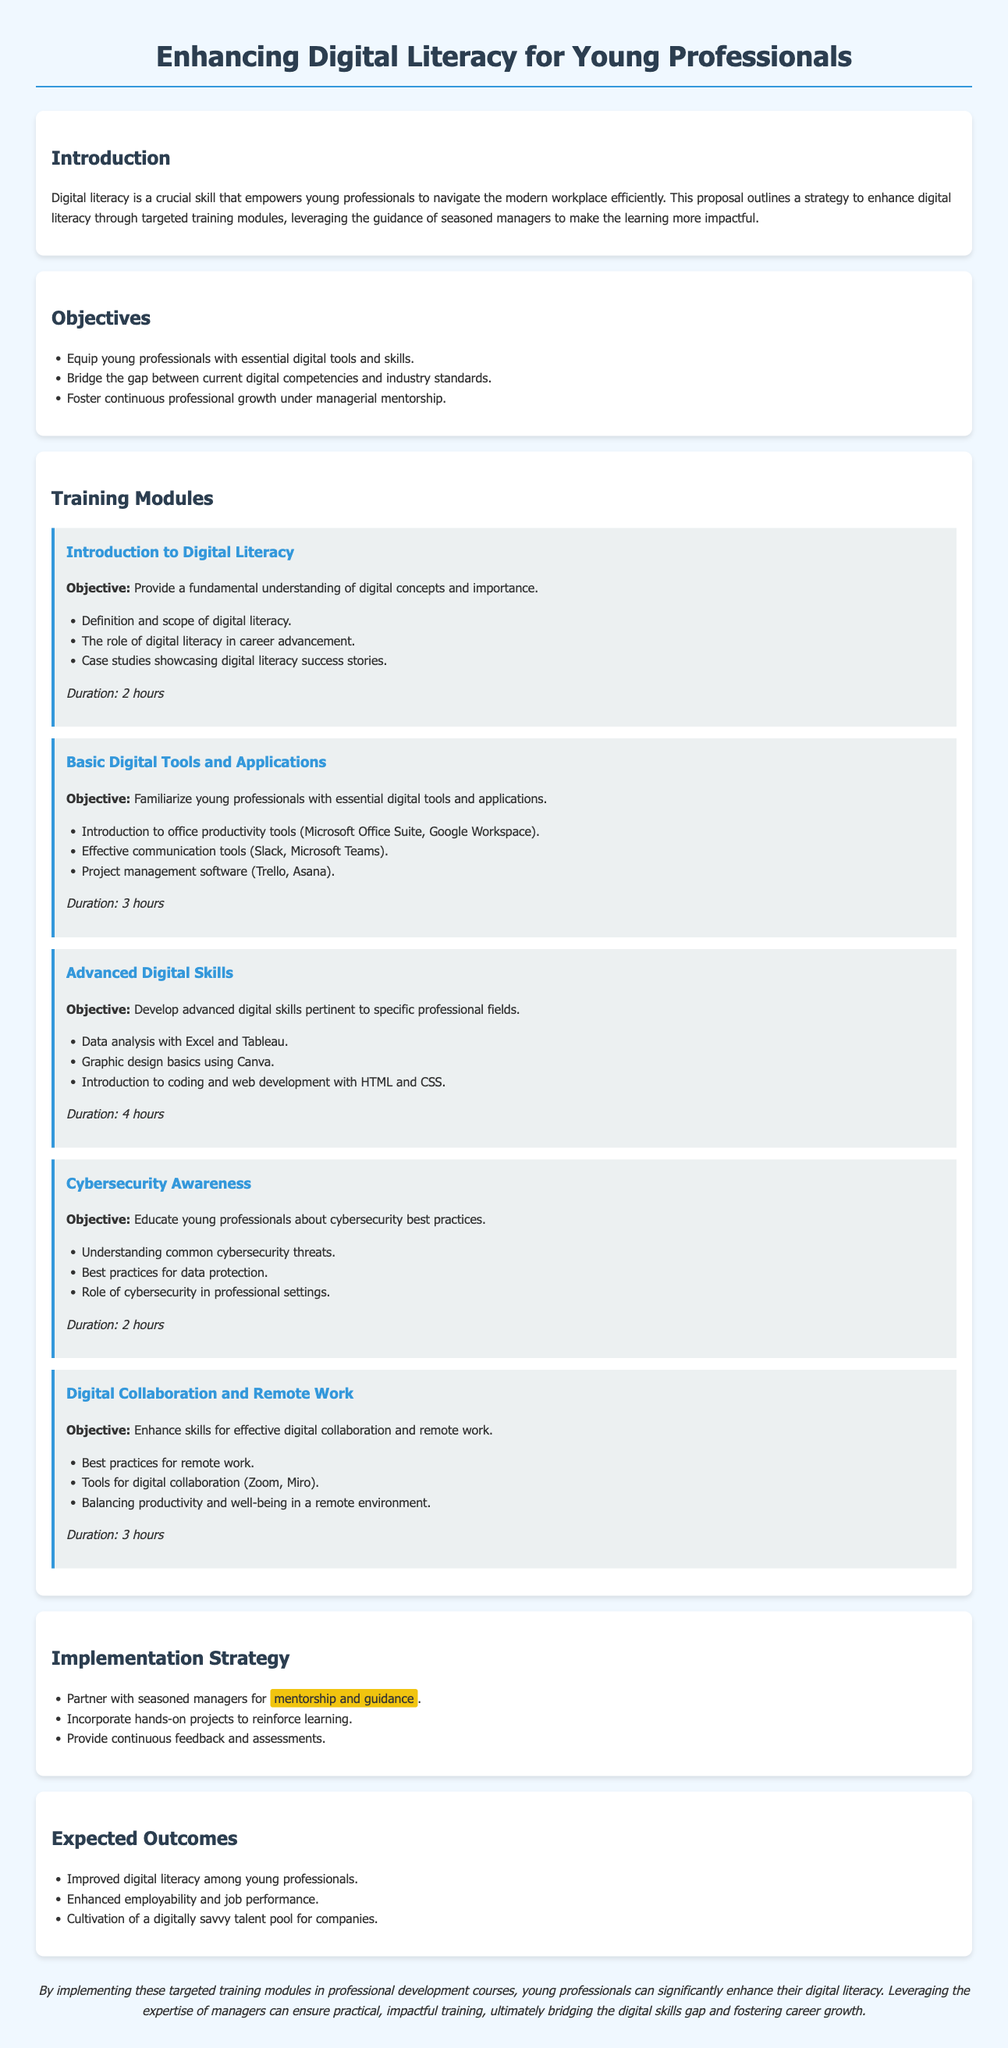What is the main focus of the proposal? The main focus of the proposal is to enhance digital literacy through targeted training modules for young professionals.
Answer: Enhance digital literacy How many training modules are proposed? The document lists five specific training modules aimed at enhancing digital literacy.
Answer: Five What is the duration of the "Basic Digital Tools and Applications" module? The duration of the module provides specific time allocated for the course, which is mentioned explicitly in the document.
Answer: 3 hours Who will provide mentorship in the training program? The proposal mentions that seasoned managers will provide mentorship and guidance during the training.
Answer: Seasoned managers What is one expected outcome of the training program? The document lists several outcomes and specifies the impact it aims to have on young professionals after the training.
Answer: Improved digital literacy What is the objective of the "Cybersecurity Awareness" module? The document outlines specific objectives for each module, indicating what each aims to educate the attendees about.
Answer: Educate young professionals about cybersecurity best practices What type of training methods are proposed in the implementation strategy? The document describes various methods for training implementation, highlighting a particular focus on practical application.
Answer: Hands-on projects How does the proposal aim to bridge the digital skills gap? The proposal discusses strategies and training approaches that collectively aim to address deficiencies in digital skills among young professionals.
Answer: Targeted training modules 